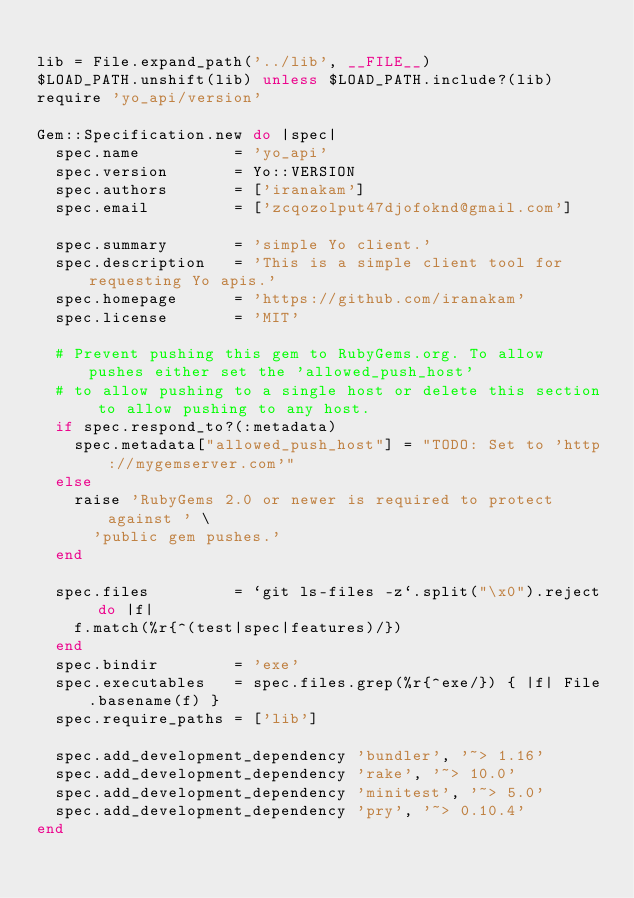Convert code to text. <code><loc_0><loc_0><loc_500><loc_500><_Ruby_>
lib = File.expand_path('../lib', __FILE__)
$LOAD_PATH.unshift(lib) unless $LOAD_PATH.include?(lib)
require 'yo_api/version'

Gem::Specification.new do |spec|
  spec.name          = 'yo_api'
  spec.version       = Yo::VERSION
  spec.authors       = ['iranakam']
  spec.email         = ['zcqozolput47djofoknd@gmail.com']

  spec.summary       = 'simple Yo client.'
  spec.description   = 'This is a simple client tool for requesting Yo apis.'
  spec.homepage      = 'https://github.com/iranakam'
  spec.license       = 'MIT'

  # Prevent pushing this gem to RubyGems.org. To allow pushes either set the 'allowed_push_host'
  # to allow pushing to a single host or delete this section to allow pushing to any host.
  if spec.respond_to?(:metadata)
    spec.metadata["allowed_push_host"] = "TODO: Set to 'http://mygemserver.com'"
  else
    raise 'RubyGems 2.0 or newer is required to protect against ' \
      'public gem pushes.'
  end

  spec.files         = `git ls-files -z`.split("\x0").reject do |f|
    f.match(%r{^(test|spec|features)/})
  end
  spec.bindir        = 'exe'
  spec.executables   = spec.files.grep(%r{^exe/}) { |f| File.basename(f) }
  spec.require_paths = ['lib']

  spec.add_development_dependency 'bundler', '~> 1.16'
  spec.add_development_dependency 'rake', '~> 10.0'
  spec.add_development_dependency 'minitest', '~> 5.0'
  spec.add_development_dependency 'pry', '~> 0.10.4'
end
</code> 